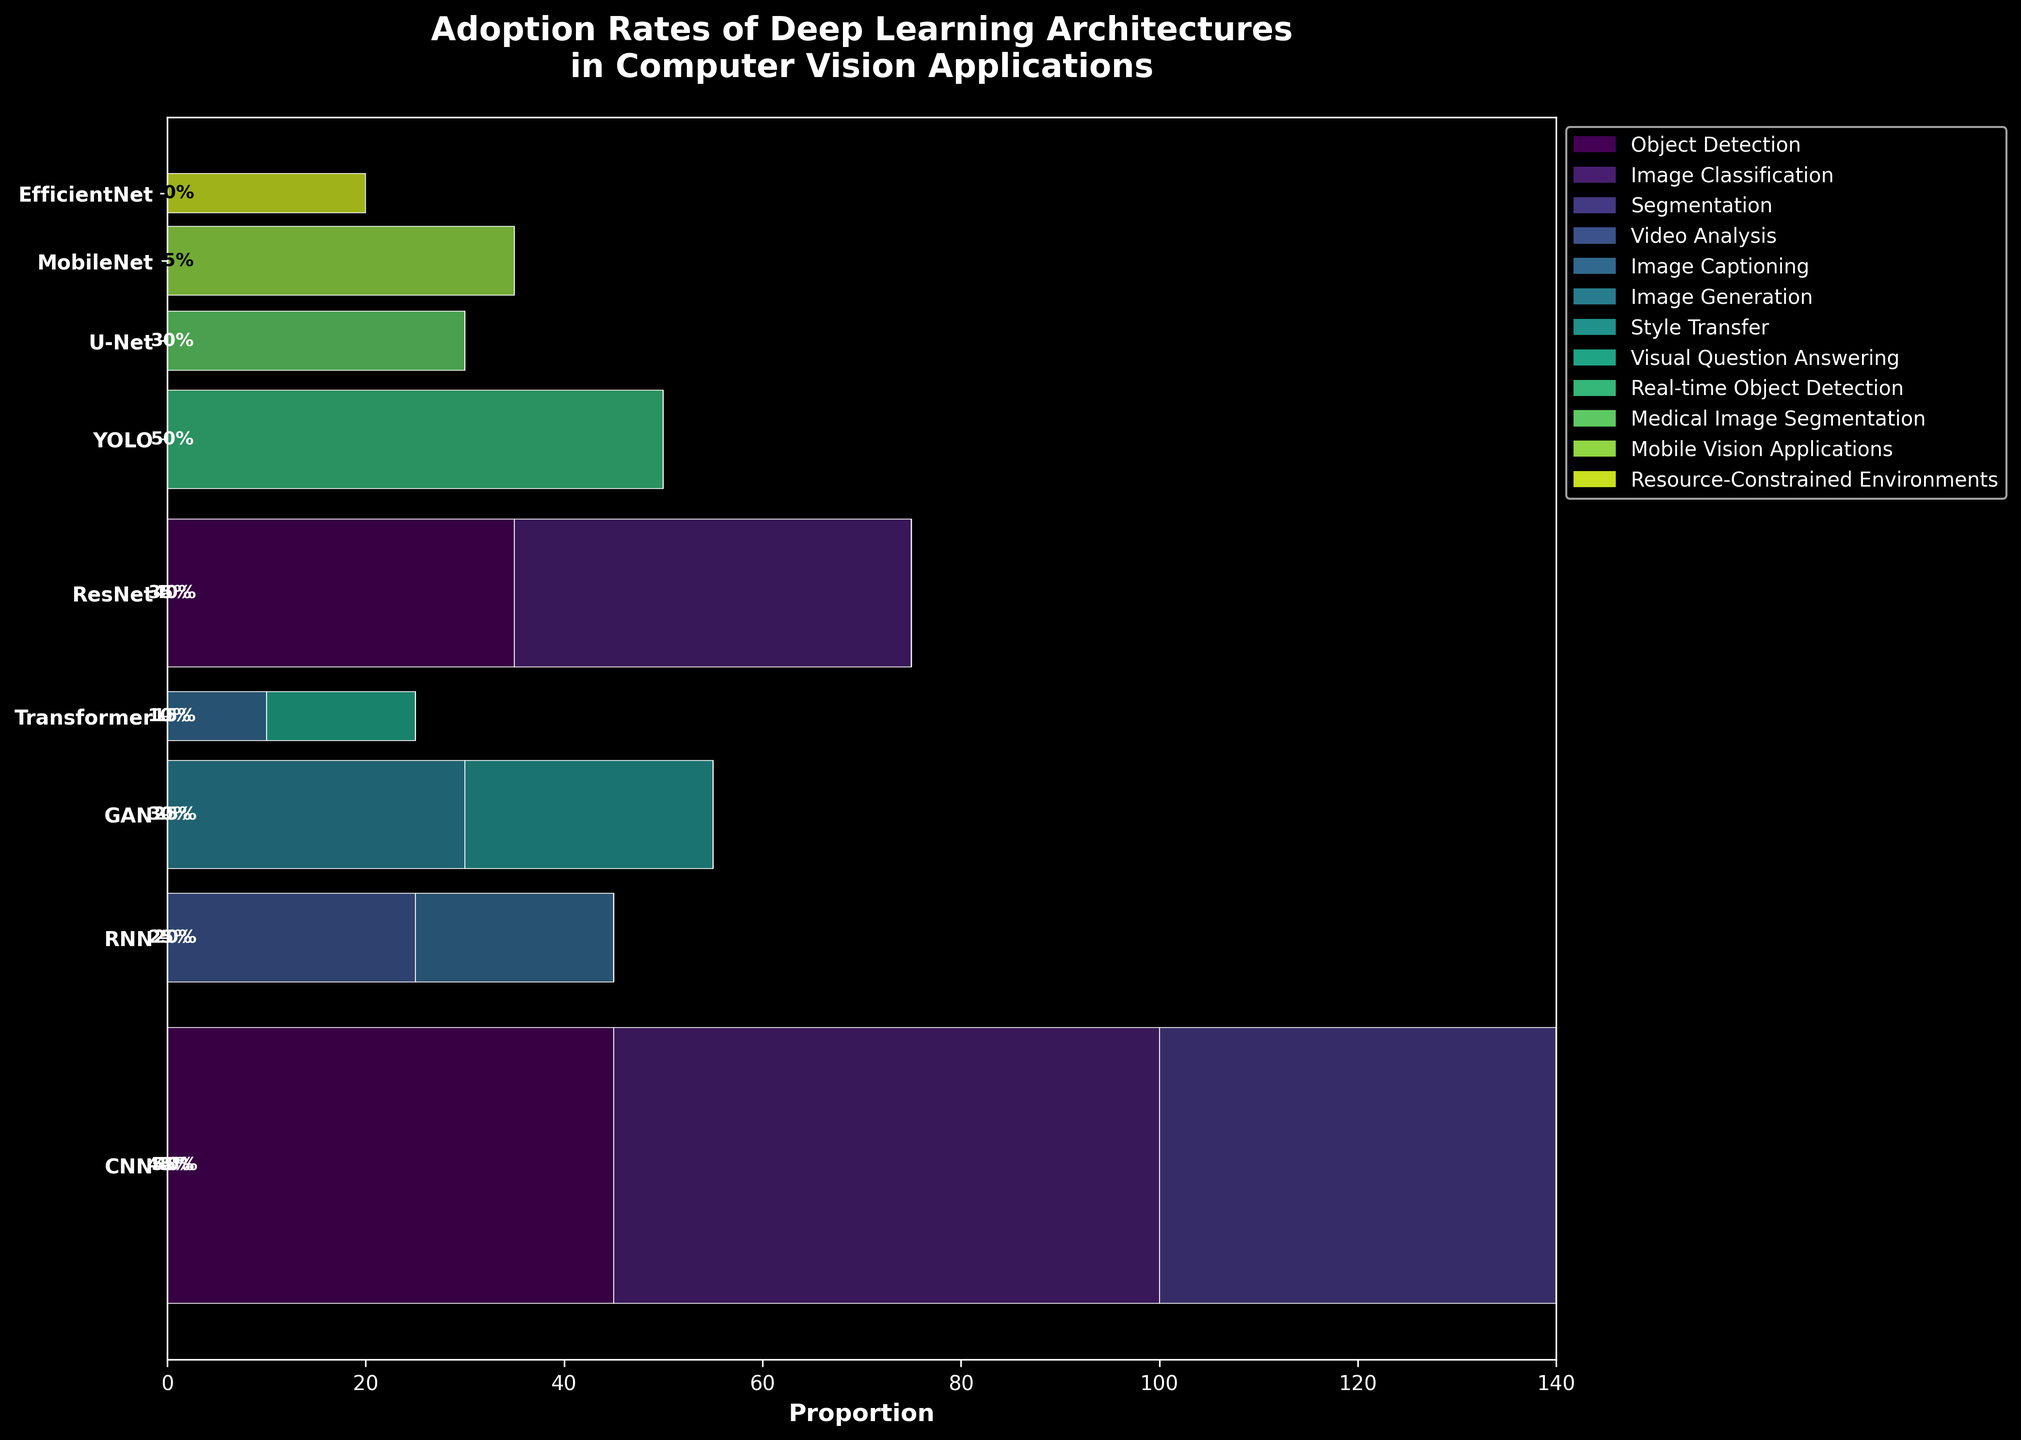What is the title of the plot? The title is typically displayed prominently at the top of the figure. It provides an overview or subject of the plot. In this case, it reads "Adoption Rates of Deep Learning Architectures in Computer Vision Applications".
Answer: Adoption Rates of Deep Learning Architectures in Computer Vision Applications Which architecture is associated with the highest adoption rate for a single application? You can identify the highest adoption rate by looking for the largest bar segment within any architecture's total bar. The YOLO architecture has the highest value for "Real-time Object Detection" with a rate of 50.
Answer: YOLO Which architecture has the most diversified applications in terms of adoption rate distribution? This can be determined by looking for an architecture with more varied widths of different colored bar segments representing different applications. The CNN architecture shows a fairly balanced distribution among Object Detection, Image Classification, and Segmentation.
Answer: CNN Which application has the widest representation across multiple architectures? To find this, look for the application color that appears most frequently across different architectures with significant widths. "Image Classification" is represented across CNN, ResNet, and other architectures.
Answer: Image Classification What is the total adoption rate for Transformer architecture across all applications? The total adoption rate is found by adding up the individual adoption rates for the Transformer in Visual Question Answering and Image Captioning. The values are 15 and 10, respectively. So, the total is 15 + 10 = 25.
Answer: 25 How does the adoption rate of CNN for Image Classification compare to ResNet for the same application? Compare the two bars representing the adoption rate of CNN and ResNet for Image Classification. For CNN, it is 55, and for ResNet, it is 40. CNN has a higher adoption rate for Image Classification.
Answer: CNN has a higher rate Name one application where GAN has a higher adoption rate than Transformer. This can be identified by comparing the height of the sections for GAN and Transformer within the same application. GAN in Image Generation or Style Transfer has higher rates (30 and 25 respectively) compared to Transformer in any application (rate 15).
Answer: Image Generation or Style Transfer Which architecture has the lowest total adoption rate? Sum the adoption rates for each architecture and find the one with the smallest total. This involves adding up each rate per architecture and comparing the sums. The Transformer has the lowest summed adoption rate (15 + 10 = 25).
Answer: Transformer Does MobileNet have a higher adoption rate in its application compared to U-Net in Medical Image Segmentation? Look at the widths of the bars for MobileNet and U-Net. MobileNet in Mobile Vision Applications has a rate of 35, while U-Net in Medical Image Segmentation has a rate of 30. MobileNet has a higher rate.
Answer: Yes Calculate the proportion of Image Captioning adoption rate in RNN architecture relative to its total adoption rate. First, find the total adoption rate for RNN, which is 25 + 20 = 45. Then, the rate for Image Captioning is 20. Dividing this by the total gives 20/45 ≈ 0.444, or approximately 44.4%.
Answer: 44.4% 